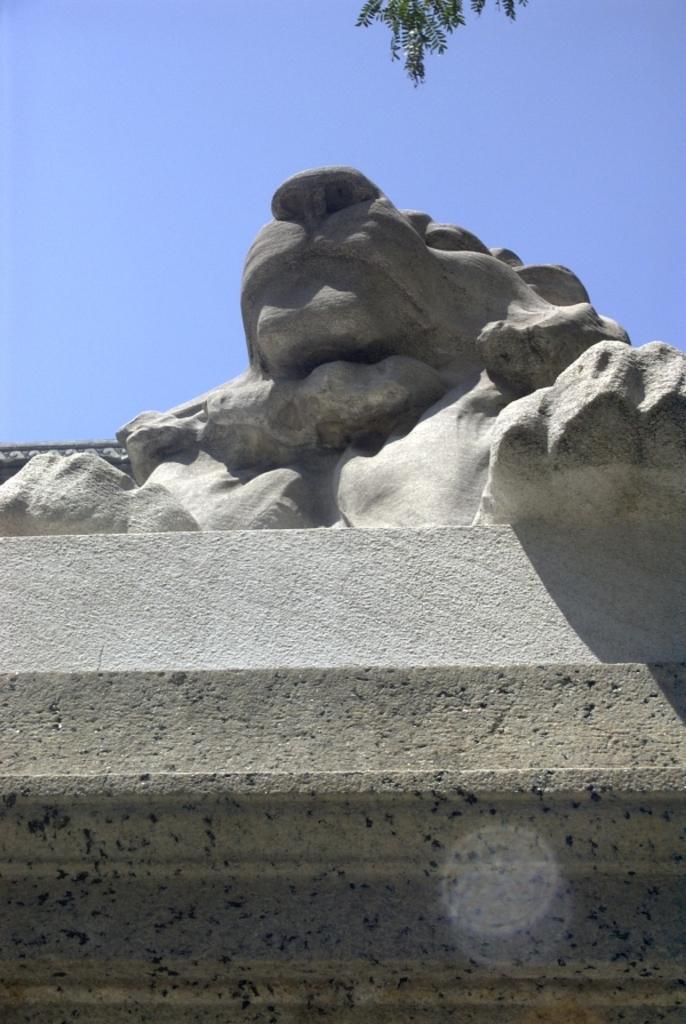How would you summarize this image in a sentence or two? In this image we can see a statue on a pedestal. In the background there is sky. At the top of the image we can see leaves. 